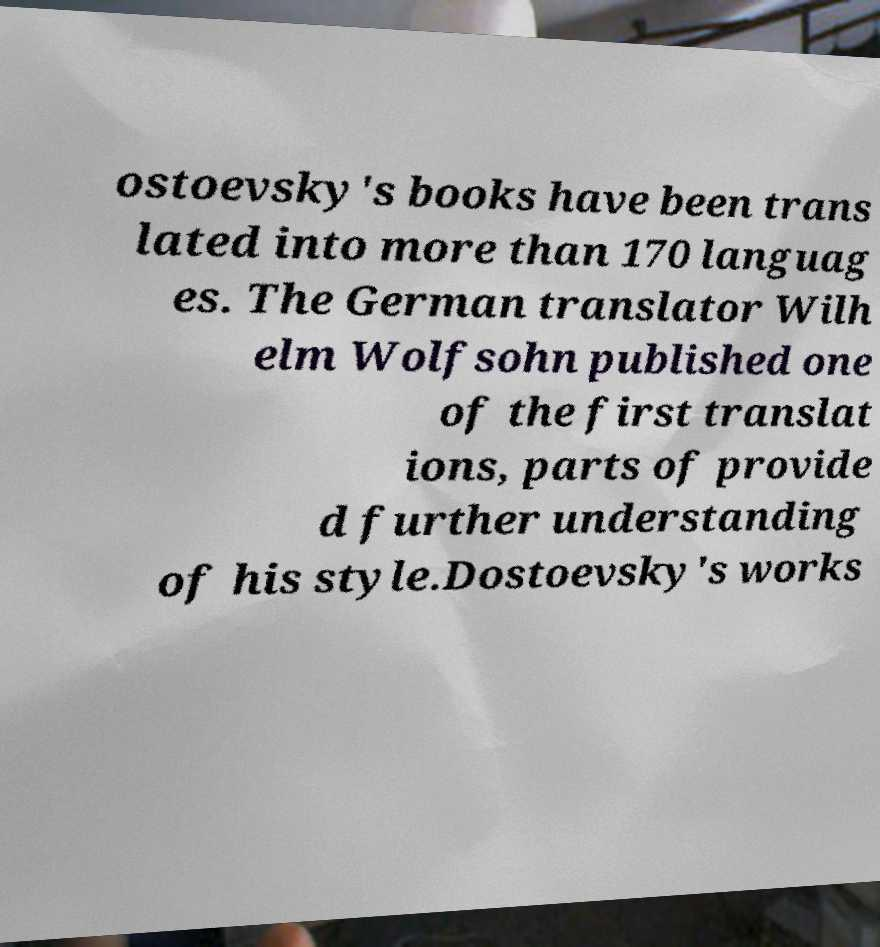Please identify and transcribe the text found in this image. ostoevsky's books have been trans lated into more than 170 languag es. The German translator Wilh elm Wolfsohn published one of the first translat ions, parts of provide d further understanding of his style.Dostoevsky's works 